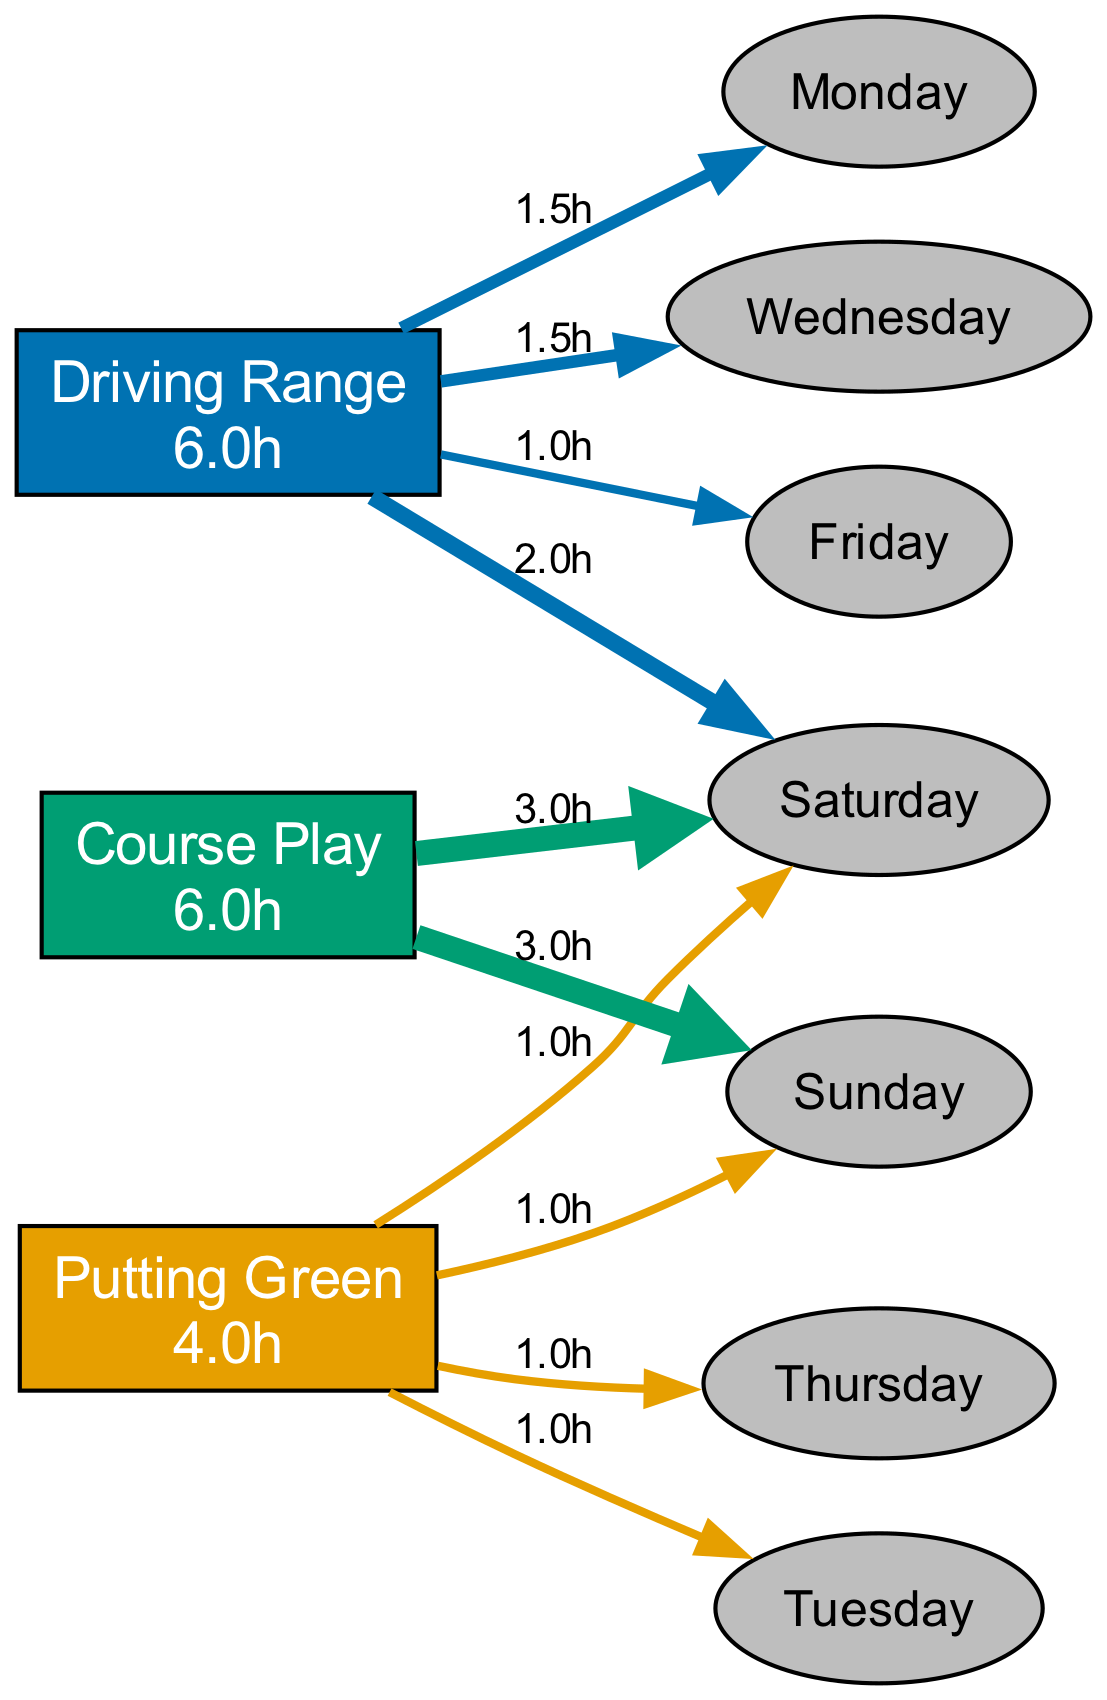What is the total time spent on the Driving Range per week? To find the total time spent on the Driving Range, we sum the hours allocated for each day: 1.5 (Monday) + 1.5 (Wednesday) + 1.0 (Friday) + 2.0 (Saturday) = 6.0 hours.
Answer: 6.0 hours How many hours are allocated for Course Play on Saturday? The diagram shows that 3.0 hours are allocated for Course Play on Saturday.
Answer: 3.0 hours Which activity has the highest total hours allocated weekly? We compare the total hours for each activity: Driving Range (6.0), Putting Green (4.0), Course Play (6.0). Both Driving Range and Course Play have the highest total of 6.0 hours.
Answer: Driving Range and Course Play How many days are dedicated to putting practice each week? By examining the Putting Green data, we see it is practiced on Tuesday, Thursday, Saturday, and Sunday, totaling four days.
Answer: 4 days What is the relationship between the Putting Green and Sunday? On Sunday, there are no hours allocated to the Putting Green, indicating no practice for that activity on that day.
Answer: No relationship What is the total number of nodes in the diagram? The nodes consist of three main activities (Driving Range, Putting Green, Course Play) and seven days (Monday, Tuesday, Wednesday, Thursday, Friday, Saturday, Sunday), totaling ten nodes.
Answer: 10 nodes On which day is the most time spent on Course Play? The diagram indicates that on both Saturday and Sunday, the same amount of time (3.0 hours) is spent on Course Play, making them tied for the highest day.
Answer: Saturday and Sunday Which day has the least total practice time across all activities? By inspecting the hours for each day, we find Tuesday (1.0 hours for Putting Green) has the least total practice time.
Answer: Tuesday What is the total practice time across all activities for the entire week? Adding all hours: Driving Range (6.0) + Putting Green (4.0) + Course Play (6.0) = 16.0 hours total for the week.
Answer: 16.0 hours 